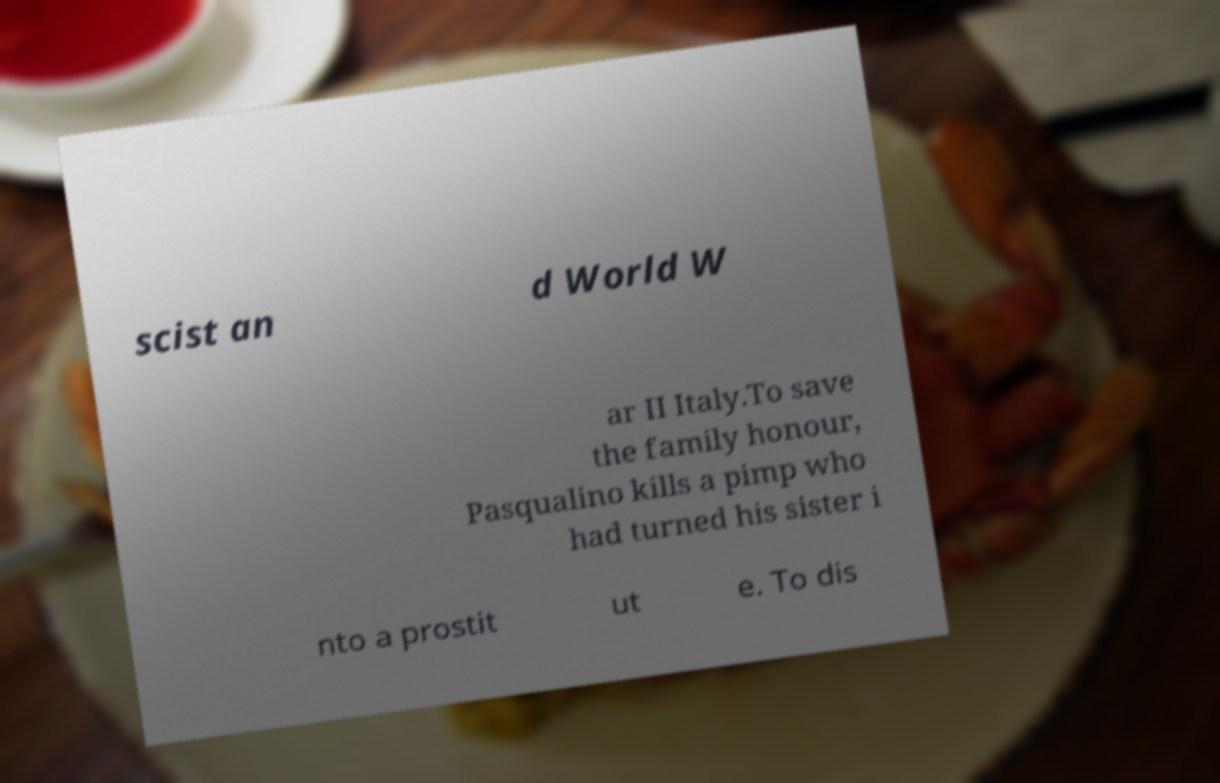Please identify and transcribe the text found in this image. scist an d World W ar II Italy.To save the family honour, Pasqualino kills a pimp who had turned his sister i nto a prostit ut e. To dis 